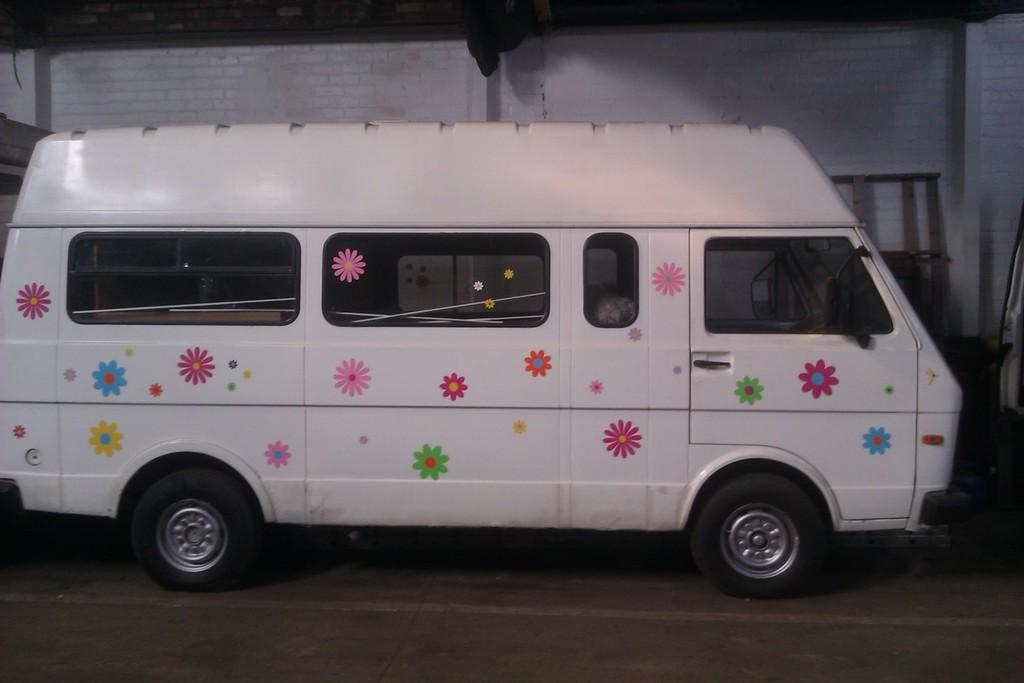What type of vehicle is featured in the image? There is a vehicle with a flower design in the image. How is the vehicle positioned in the image? The vehicle is placed on the ground. What can be seen in the background of the image? There is a wall in the background of the image. Can you see a pocket on the vehicle in the image? There is no pocket visible on the vehicle in the image. What type of sponge is being used to clean the wall in the image? There is no sponge or cleaning activity depicted in the image. 